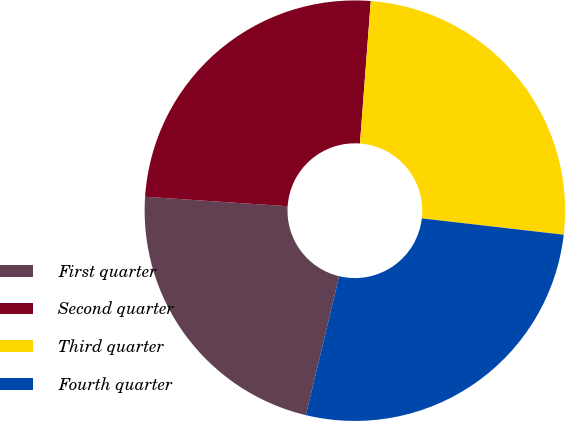Convert chart. <chart><loc_0><loc_0><loc_500><loc_500><pie_chart><fcel>First quarter<fcel>Second quarter<fcel>Third quarter<fcel>Fourth quarter<nl><fcel>22.31%<fcel>25.15%<fcel>25.62%<fcel>26.92%<nl></chart> 